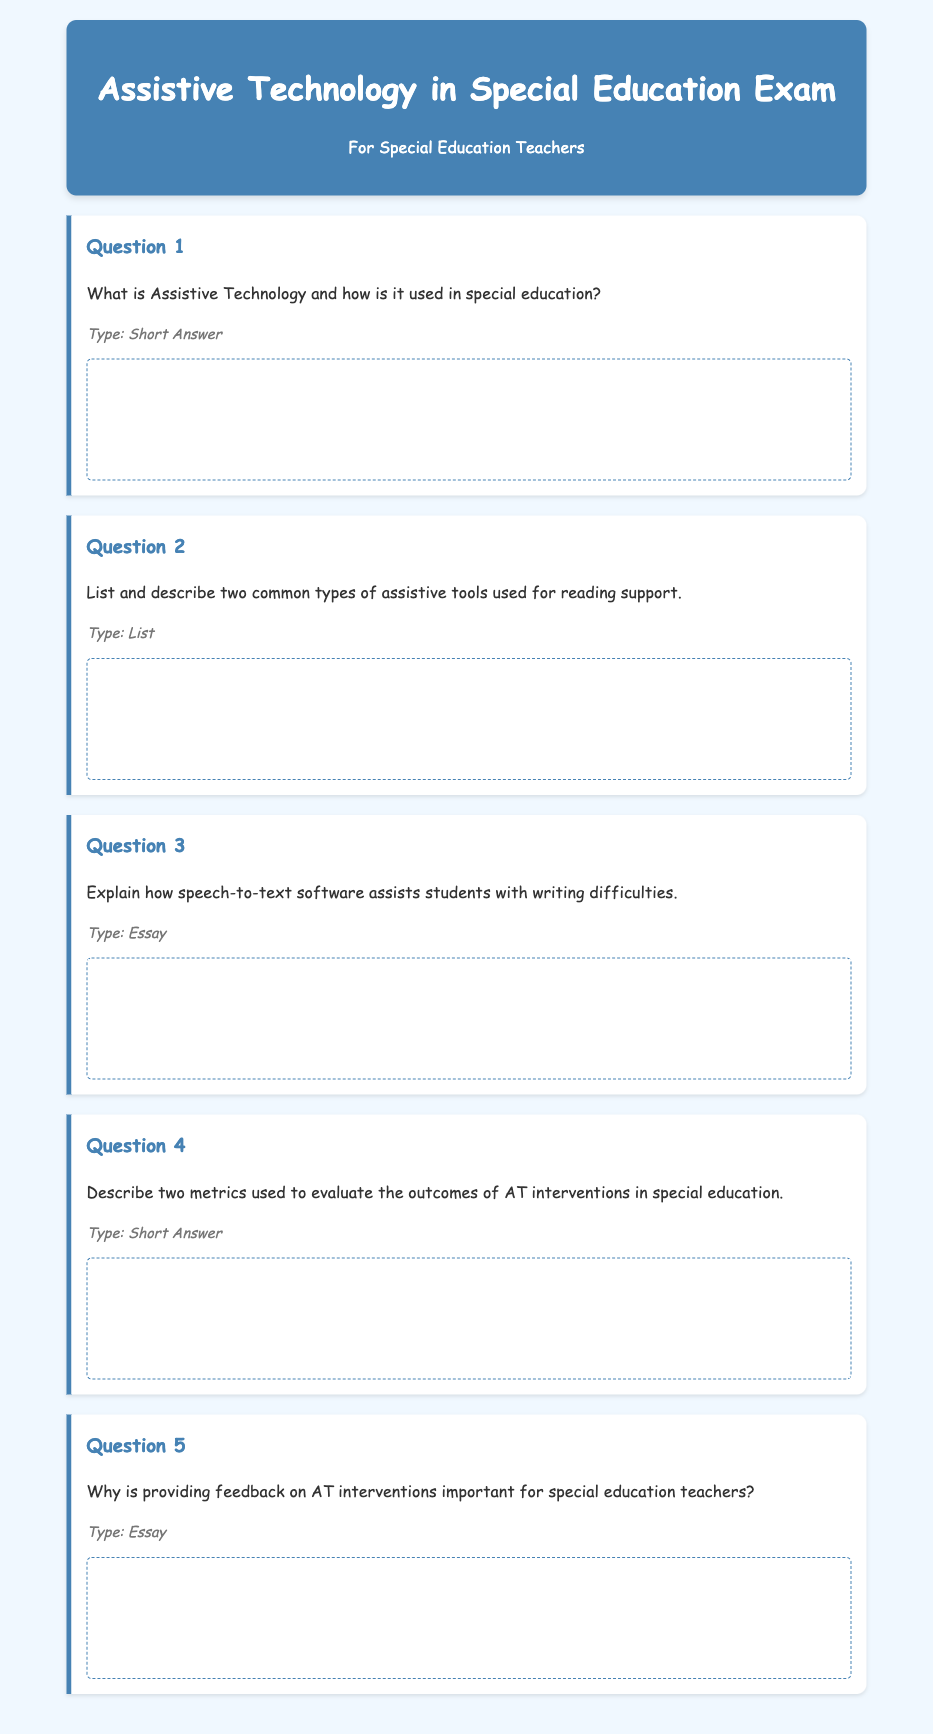What is the title of the exam? The title of the exam is stated in the header section of the document, which is "Assistive Technology in Special Education Exam."
Answer: Assistive Technology in Special Education Exam Who is the exam intended for? The intended audience of the exam is mentioned in the subtitle, "For Special Education Teachers."
Answer: For Special Education Teachers How many questions are included in the exam? The exam consists of five questions as listed in the document.
Answer: 5 What is the style of the font used in the document? The font used in the document is specified in the CSS style settings, which is 'Comic Sans MS.'
Answer: Comic Sans MS What type of questions does Question 3 ask? The type of question for Question 3 is indicated as "Essay" in the document.
Answer: Essay 